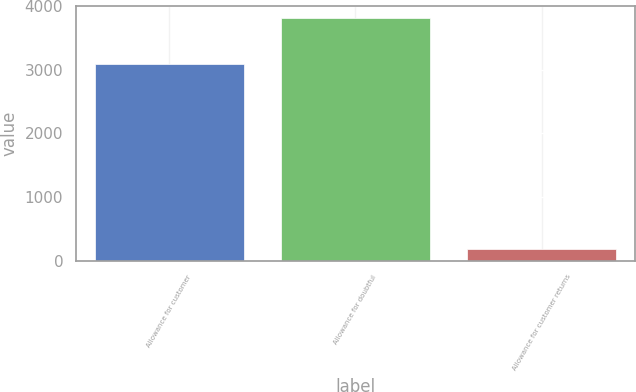<chart> <loc_0><loc_0><loc_500><loc_500><bar_chart><fcel>Allowance for customer<fcel>Allowance for doubtful<fcel>Allowance for customer returns<nl><fcel>3094<fcel>3813<fcel>176<nl></chart> 